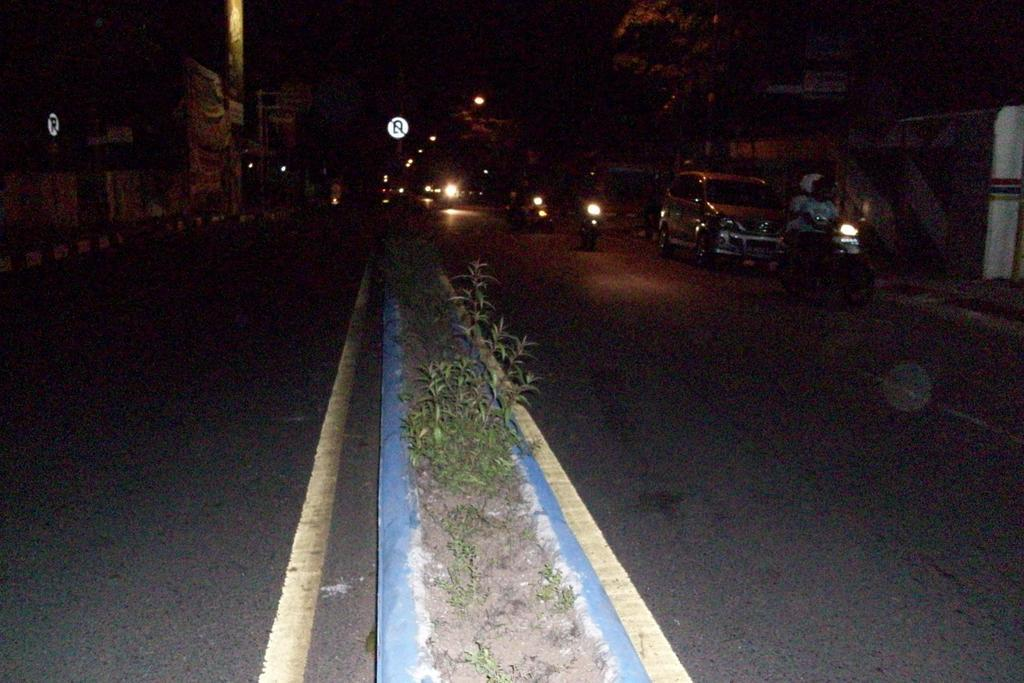What can be seen moving on the roads in the image? There are vehicles on the roads in the image. What type of vegetation is present in the image? There are plants and trees in the image. What can be seen providing information or directions in the image? There are sign boards in the image. What can be seen providing illumination in the image? There are lights in the image. What type of punishment is being carried out on the trees in the image? There is no punishment being carried out on the trees in the image; they are simply present in the scene. Can you describe the exchange happening between the plants and vehicles in the image? There is no exchange happening between the plants and vehicles in the image; they are separate entities in the scene. 